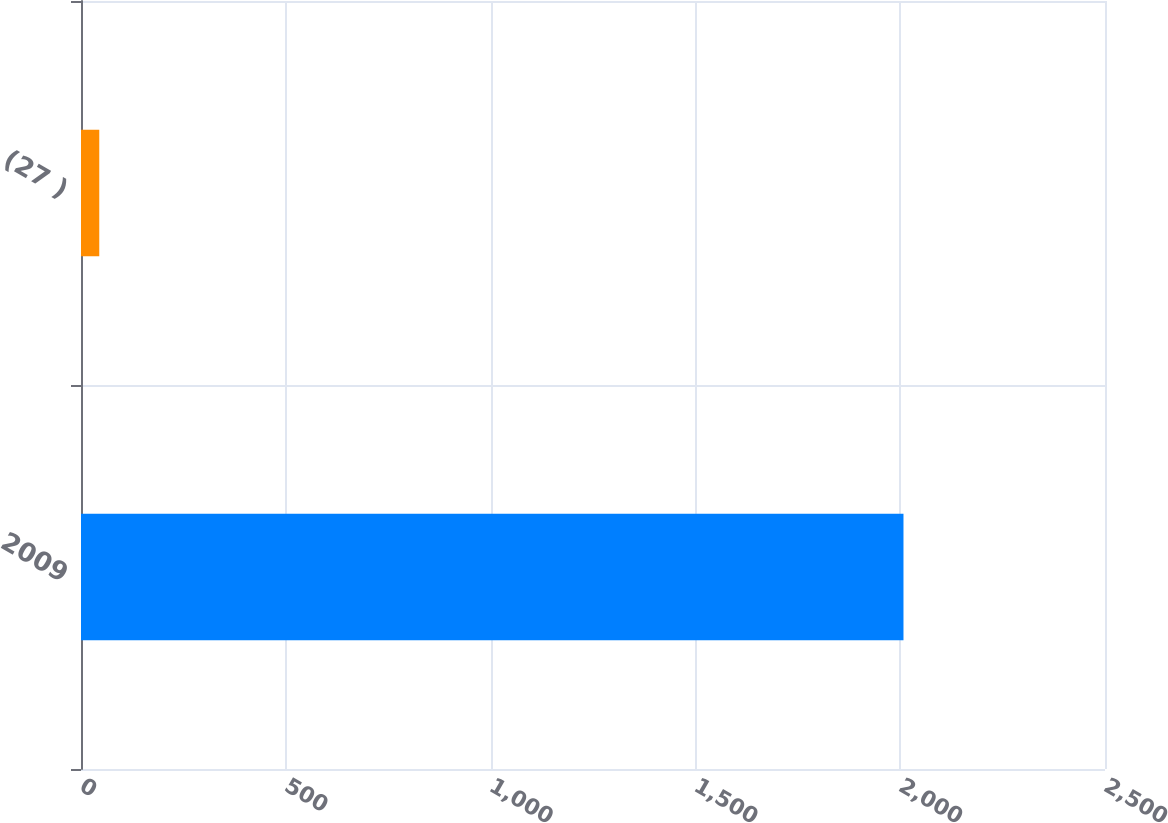Convert chart to OTSL. <chart><loc_0><loc_0><loc_500><loc_500><bar_chart><fcel>2009<fcel>(27 )<nl><fcel>2008<fcel>44.6<nl></chart> 